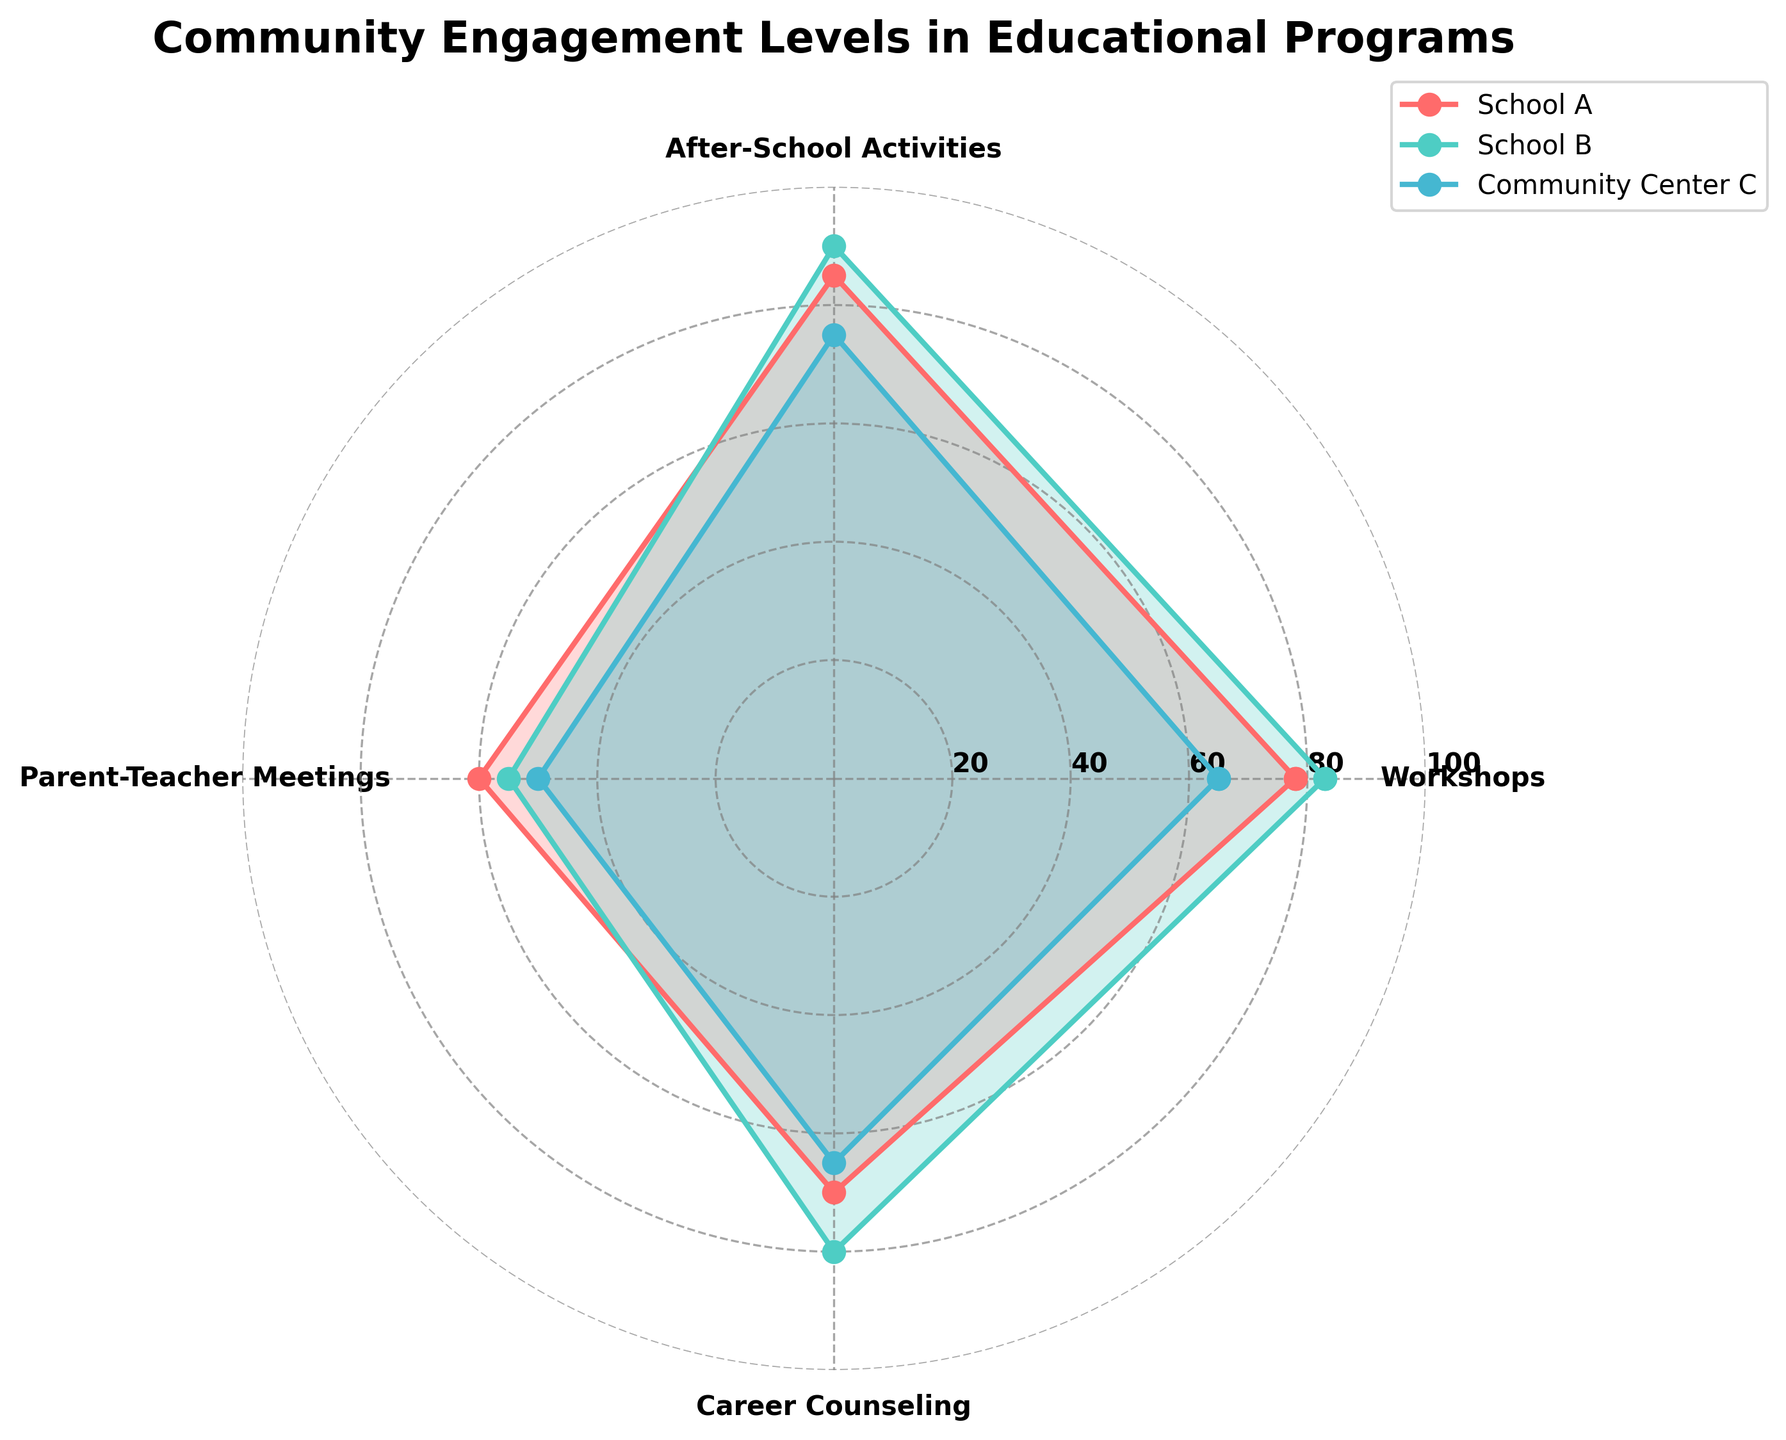what is the title of the figure? The title is displayed prominently at the top of the radar chart. It is typically in a larger or bold font for emphasis.
Answer: Community Engagement Levels in Educational Programs how many data points are there for each school? There are four categories: Workshops, After-School Activities, Parent-Teacher Meetings, and Career Counseling. Each school has one data point per category.
Answer: 4 which school has the highest engagement level in After-School Activities? By looking at the radar chart's After-School Activities axis, we can see that the engagement level for School B reaches the highest point compared to other schools.
Answer: School B what is the average engagement level for school A across all categories? Add the engagement levels for each category in School A: 78 (Workshops) + 85 (After-School Activities) + 60 (Parent-Teacher Meetings) + 70 (Career Counseling), then divide by 4. (78 + 85 + 60 + 70) / 4 = 293 / 4.
Answer: 73.25 which program has the largest range of engagement levels among the schools? Calculate the range for each category by finding the difference between the highest and lowest values. The ranges are: Workshops (83-65), After-School Activities (90-75), Parent-Teacher Meetings (60-50), Career Counseling (80-65). The category with the largest range is After-School Activities (90 - 75).
Answer: After-School Activities what is the difference in engagement levels between School A and Community Center C for Parent-Teacher Meetings? Compare the engagement levels for Parent-Teacher Meetings: School A (60) and Community Center C (50). Calculate the difference by subtracting 50 from 60.
Answer: 10 which school has the most balanced engagement levels across all categories? Look for the school whose radar chart lines and the filled area are most evenly distributed around the center across all categories. This visual representation implies balanced engagement levels.
Answer: School A which school shows the highest engagement level in Career Counseling? By looking at the radar chart's Career Counseling axis, we can see that the engagement level for School B reaches the highest point compared to other schools.
Answer: School B compare the engagement levels in Workshops between Community Center C and Educational Nonprofit D. Which has higher engagement, and by how much? Check the values on the radar chart for Workshops: Community Center C (65) and Educational Nonprofit D (70). Subtract 65 from 70. Educational Nonprofit D has a higher engagement by 5 points.
Answer: Educational Nonprofit D, 5 